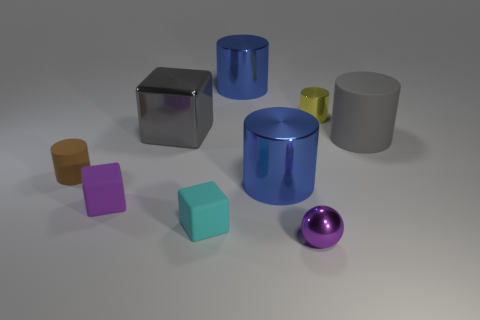Subtract all gray cylinders. How many cylinders are left? 4 Subtract all tiny rubber cylinders. How many cylinders are left? 4 Subtract all red cylinders. Subtract all red cubes. How many cylinders are left? 5 Add 1 yellow metal cylinders. How many objects exist? 10 Subtract all spheres. How many objects are left? 8 Add 5 big blocks. How many big blocks are left? 6 Add 1 small red rubber cubes. How many small red rubber cubes exist? 1 Subtract 1 yellow cylinders. How many objects are left? 8 Subtract all purple matte objects. Subtract all shiny objects. How many objects are left? 3 